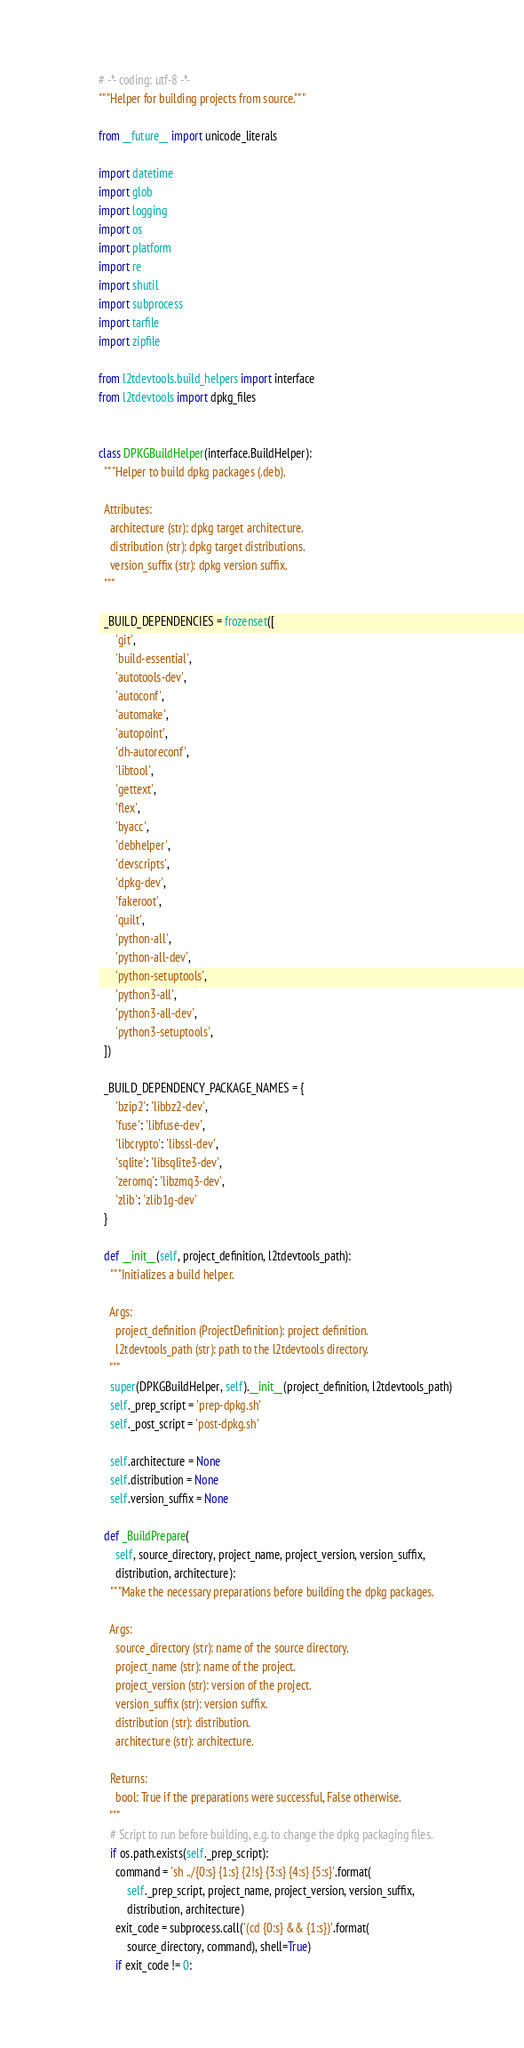<code> <loc_0><loc_0><loc_500><loc_500><_Python_># -*- coding: utf-8 -*-
"""Helper for building projects from source."""

from __future__ import unicode_literals

import datetime
import glob
import logging
import os
import platform
import re
import shutil
import subprocess
import tarfile
import zipfile

from l2tdevtools.build_helpers import interface
from l2tdevtools import dpkg_files


class DPKGBuildHelper(interface.BuildHelper):
  """Helper to build dpkg packages (.deb).

  Attributes:
    architecture (str): dpkg target architecture.
    distribution (str): dpkg target distributions.
    version_suffix (str): dpkg version suffix.
  """

  _BUILD_DEPENDENCIES = frozenset([
      'git',
      'build-essential',
      'autotools-dev',
      'autoconf',
      'automake',
      'autopoint',
      'dh-autoreconf',
      'libtool',
      'gettext',
      'flex',
      'byacc',
      'debhelper',
      'devscripts',
      'dpkg-dev',
      'fakeroot',
      'quilt',
      'python-all',
      'python-all-dev',
      'python-setuptools',
      'python3-all',
      'python3-all-dev',
      'python3-setuptools',
  ])

  _BUILD_DEPENDENCY_PACKAGE_NAMES = {
      'bzip2': 'libbz2-dev',
      'fuse': 'libfuse-dev',
      'libcrypto': 'libssl-dev',
      'sqlite': 'libsqlite3-dev',
      'zeromq': 'libzmq3-dev',
      'zlib': 'zlib1g-dev'
  }

  def __init__(self, project_definition, l2tdevtools_path):
    """Initializes a build helper.

    Args:
      project_definition (ProjectDefinition): project definition.
      l2tdevtools_path (str): path to the l2tdevtools directory.
    """
    super(DPKGBuildHelper, self).__init__(project_definition, l2tdevtools_path)
    self._prep_script = 'prep-dpkg.sh'
    self._post_script = 'post-dpkg.sh'

    self.architecture = None
    self.distribution = None
    self.version_suffix = None

  def _BuildPrepare(
      self, source_directory, project_name, project_version, version_suffix,
      distribution, architecture):
    """Make the necessary preparations before building the dpkg packages.

    Args:
      source_directory (str): name of the source directory.
      project_name (str): name of the project.
      project_version (str): version of the project.
      version_suffix (str): version suffix.
      distribution (str): distribution.
      architecture (str): architecture.

    Returns:
      bool: True if the preparations were successful, False otherwise.
    """
    # Script to run before building, e.g. to change the dpkg packaging files.
    if os.path.exists(self._prep_script):
      command = 'sh ../{0:s} {1:s} {2!s} {3:s} {4:s} {5:s}'.format(
          self._prep_script, project_name, project_version, version_suffix,
          distribution, architecture)
      exit_code = subprocess.call('(cd {0:s} && {1:s})'.format(
          source_directory, command), shell=True)
      if exit_code != 0:</code> 